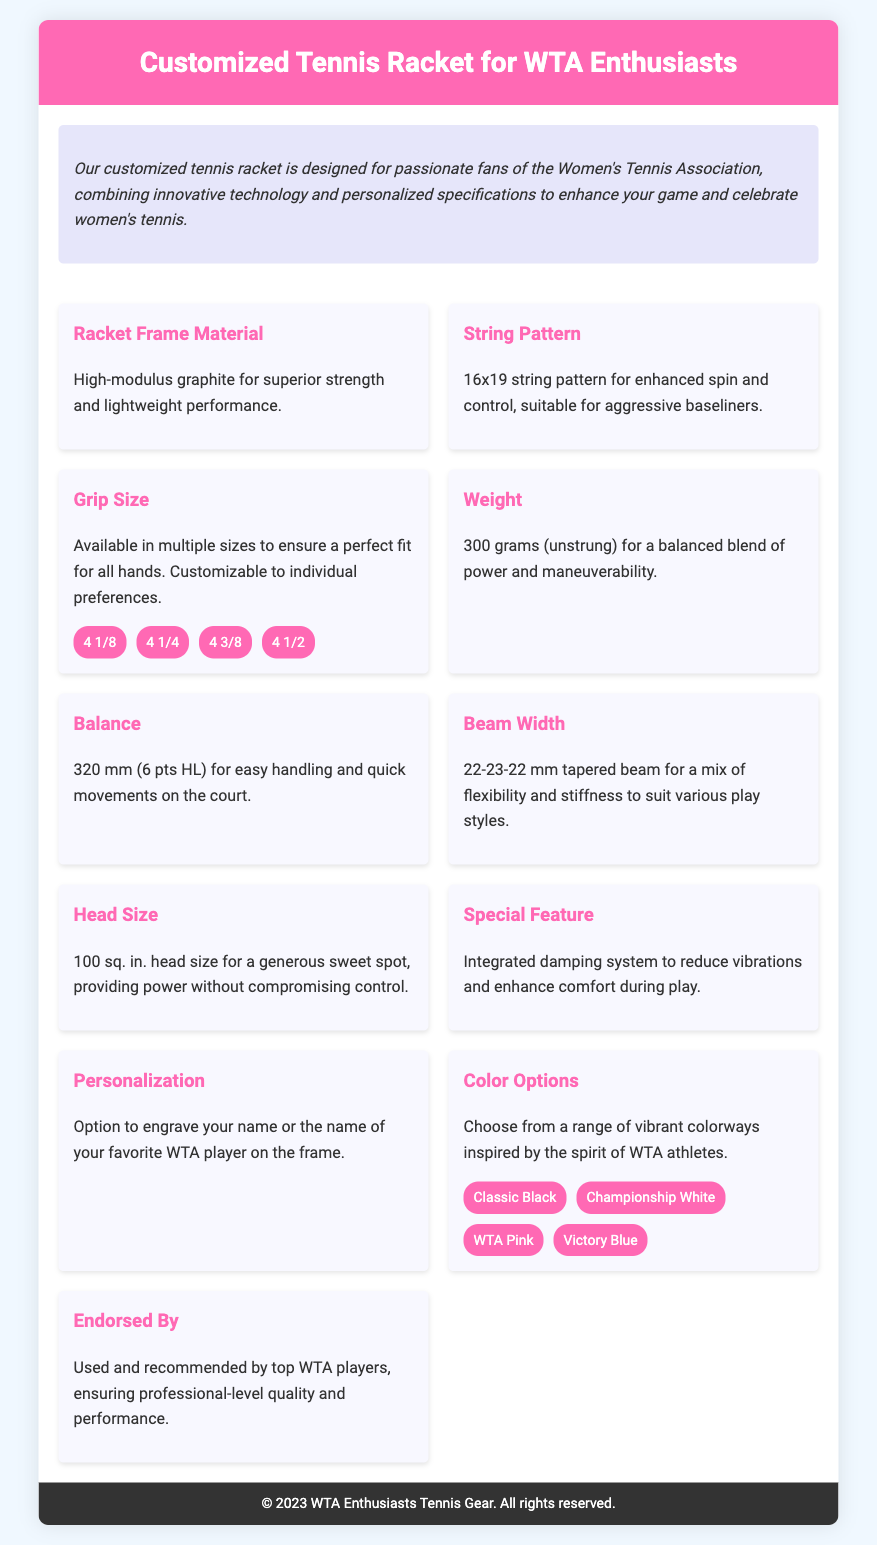What is the racket frame material? The material of the racket frame is specified as high-modulus graphite, which is noted for its strength and lightweight performance.
Answer: High-modulus graphite What is the string pattern? The document specifies the string pattern, highlighting its configuration that enhances play style advantages.
Answer: 16x19 What weight is the racket (unstrung)? The weight of the racket is presented in grams and noted clearly in the specifications.
Answer: 300 grams What is the balance measurement? The balance specification includes a precise measurement that aids in racket handling and speed, which is clearly detailed in the text.
Answer: 320 mm What customization options are available for grip size? The rackets are offered in various grip sizes to accommodate different hand sizes, enumerated in the document.
Answer: 4 1/8, 4 1/4, 4 3/8, 4 1/2 What unique feature enhances comfort during play? A special feature is mentioned that reduces vibrations and increases player satisfaction, which stands out in the specifications area.
Answer: Integrated damping system What color options are offered? This section lists choices available for the racket’s appearance, inspired by WTA athletes, which conveys the brand personality.
Answer: Classic Black, Championship White, WTA Pink, Victory Blue Which players endorse the racket? The document highlights the endorsement by professional-level athletes, reinforcing the product's appeal and credibility.
Answer: Top WTA players What type of personalization can be added? The personalization options reflect a unique offering for fans, making the product more special and tailored to users.
Answer: Engrave your name or the name of your favorite WTA player 